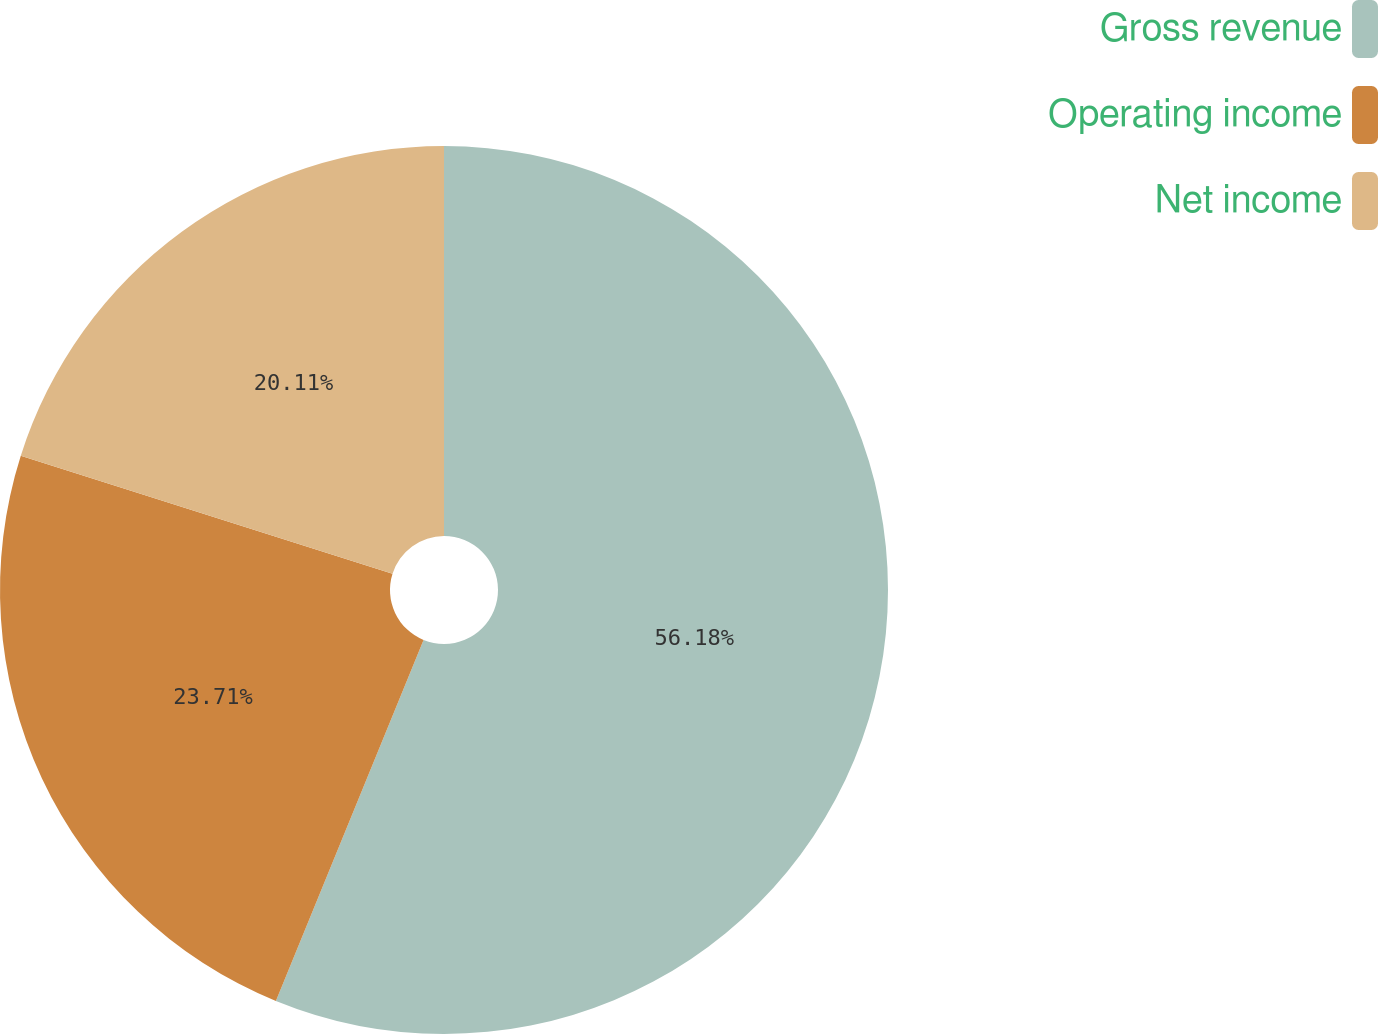Convert chart. <chart><loc_0><loc_0><loc_500><loc_500><pie_chart><fcel>Gross revenue<fcel>Operating income<fcel>Net income<nl><fcel>56.18%<fcel>23.71%<fcel>20.11%<nl></chart> 